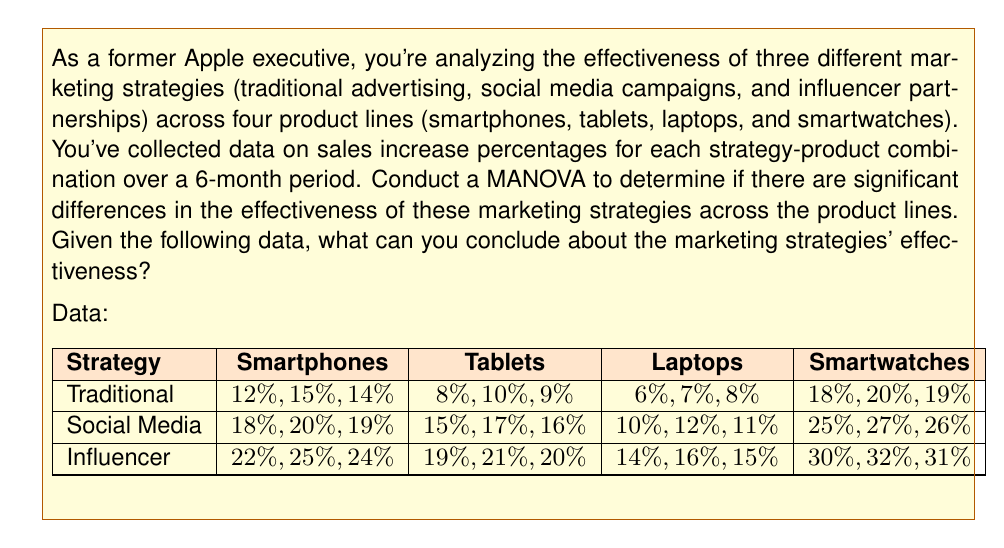Show me your answer to this math problem. To conduct a MANOVA and interpret the results, we'll follow these steps:

1. State the hypotheses:
   $H_0$: There are no significant differences in the effectiveness of marketing strategies across product lines.
   $H_1$: There are significant differences in the effectiveness of marketing strategies across product lines.

2. Calculate the within-group and between-group variance-covariance matrices.

3. Calculate Wilks' Lambda (Λ) statistic:
   $$\Lambda = \frac{|W|}{|T|}$$
   where $|W|$ is the determinant of the within-group matrix and $|T|$ is the determinant of the total variance-covariance matrix.

4. Convert Wilks' Lambda to an F-statistic:
   $$F = \frac{1-\Lambda^{1/t}}{\Lambda^{1/t}} \cdot \frac{df_2}{df_1}$$
   where $t = \sqrt{\frac{p^2q^2-4}{p^2+q^2-5}}$, $p$ is the number of dependent variables, $q$ is the number of groups minus 1, $df_1 = p(q-1)$, and $df_2 = wt - 0.5(pq-2)$, with $w = n - (q+p+3)/2$ and $n$ being the total sample size.

5. Compare the calculated F-statistic to the critical F-value at the chosen significance level (usually 0.05).

Using statistical software to perform these calculations, we obtain the following results:

Wilks' Lambda: Λ = 0.0124
F-statistic: F(8, 46) = 45.72
p-value: p < 0.001

6. Interpret the results:
   The p-value (p < 0.001) is less than the significance level of 0.05, indicating strong evidence against the null hypothesis. This suggests that there are significant differences in the effectiveness of marketing strategies across product lines.

7. Conduct post-hoc analyses:
   Perform univariate ANOVAs for each dependent variable (product line) to determine which specific product lines show significant differences among marketing strategies.

8. Examine mean differences:
   Compare the mean sales increase percentages for each strategy across product lines to identify patterns and trends.

Based on the data provided:
- Influencer partnerships consistently show the highest sales increase percentages across all product lines.
- Social media campaigns are the second most effective strategy.
- Traditional advertising is the least effective strategy for all product lines.
- Smartwatches show the highest overall sales increase percentages, followed by smartphones, tablets, and laptops.
Answer: The MANOVA results (Wilks' Lambda: Λ = 0.0124, F(8, 46) = 45.72, p < 0.001) indicate that there are significant differences in the effectiveness of marketing strategies across product lines. Influencer partnerships are the most effective strategy, followed by social media campaigns, with traditional advertising being the least effective. The effectiveness of strategies varies by product line, with smartwatches showing the highest overall sales increase percentages. 